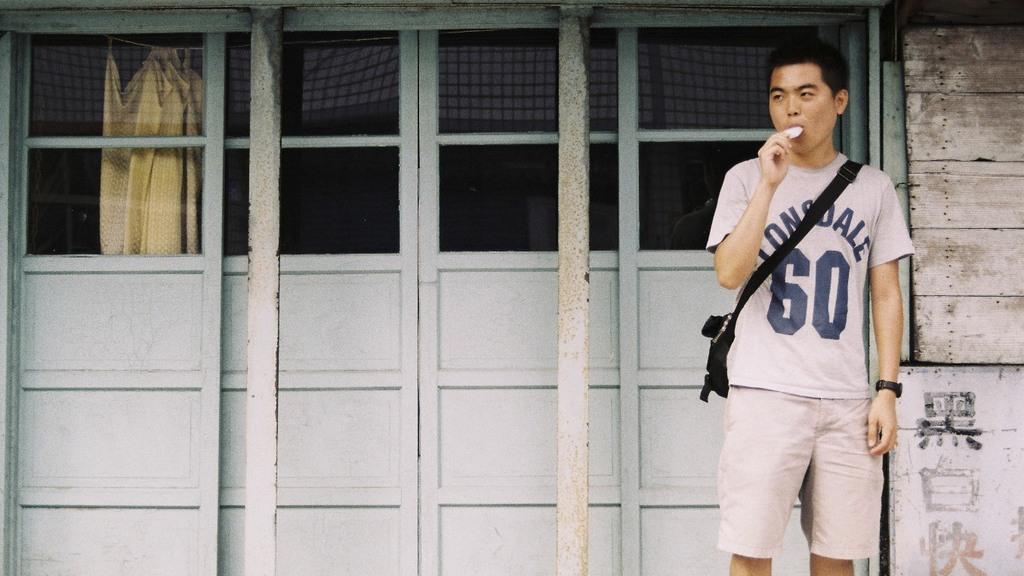What team name is on the man's t-shirt?
Keep it short and to the point. Lonsdale. What number is on his shirt?
Keep it short and to the point. 60. 